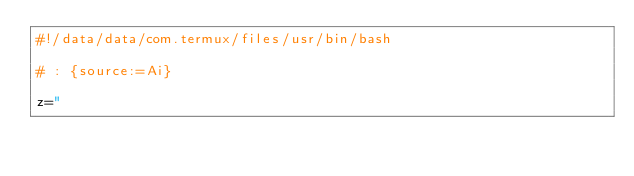<code> <loc_0><loc_0><loc_500><loc_500><_Bash_>#!/data/data/com.termux/files/usr/bin/bash

# : {source:=Ai}

z="</code> 